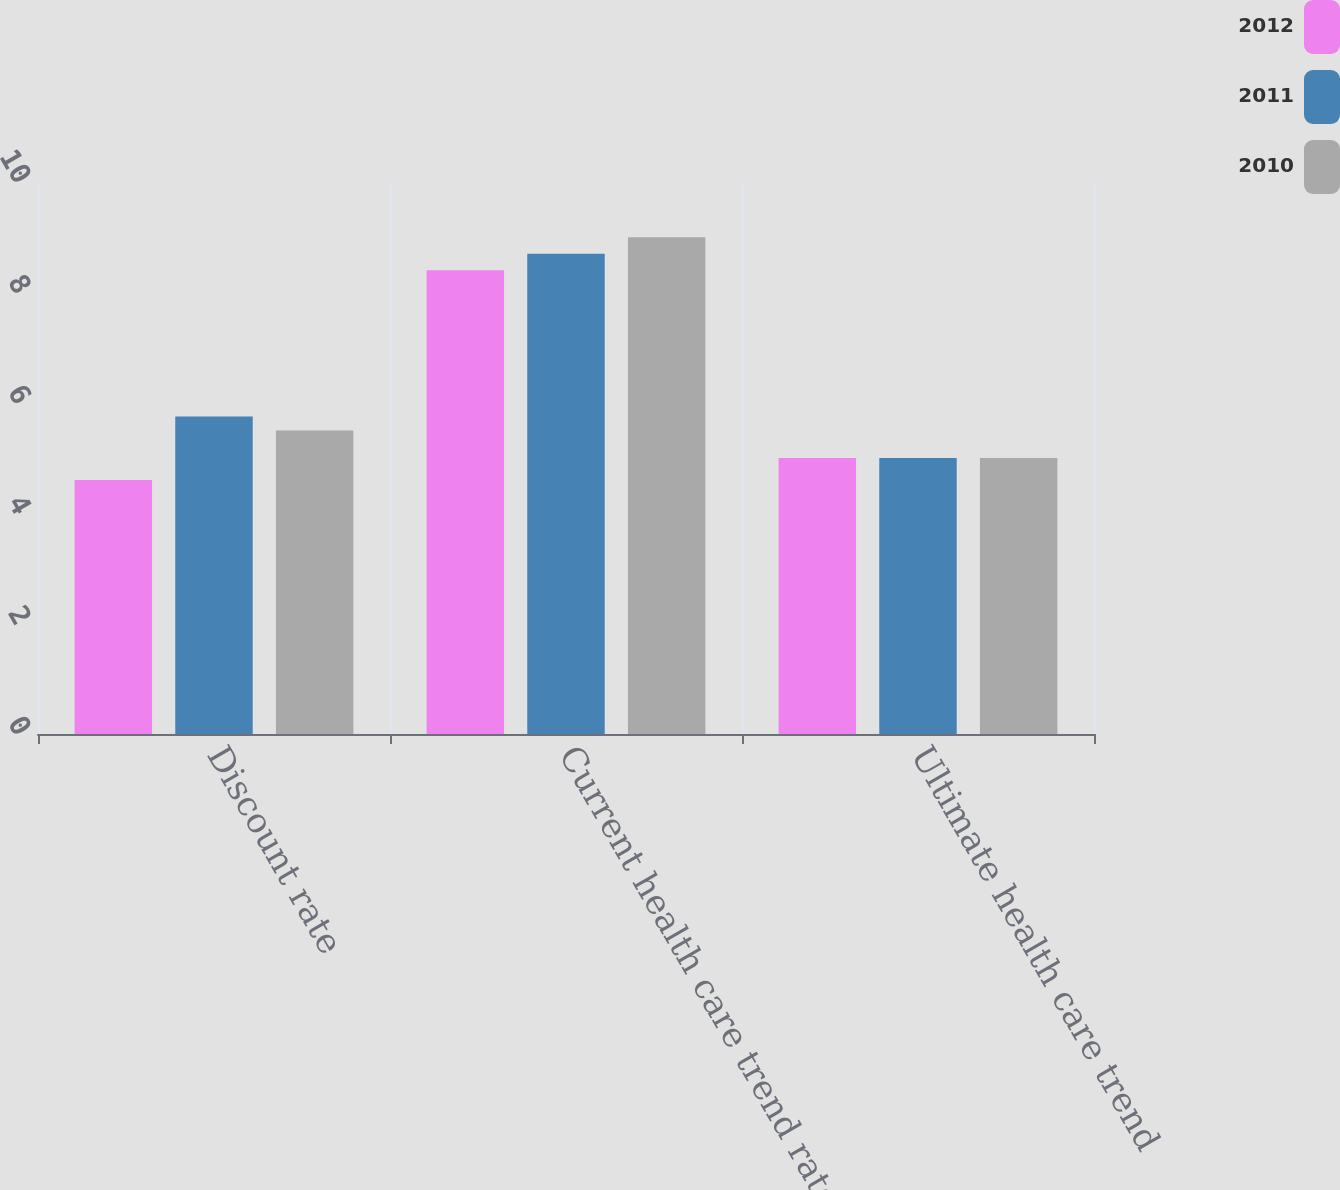<chart> <loc_0><loc_0><loc_500><loc_500><stacked_bar_chart><ecel><fcel>Discount rate<fcel>Current health care trend rate<fcel>Ultimate health care trend<nl><fcel>2012<fcel>4.6<fcel>8.4<fcel>5<nl><fcel>2011<fcel>5.75<fcel>8.7<fcel>5<nl><fcel>2010<fcel>5.5<fcel>9<fcel>5<nl></chart> 